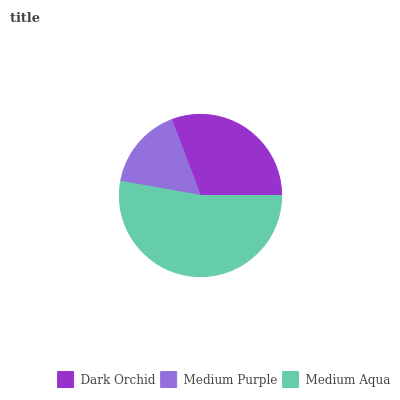Is Medium Purple the minimum?
Answer yes or no. Yes. Is Medium Aqua the maximum?
Answer yes or no. Yes. Is Medium Aqua the minimum?
Answer yes or no. No. Is Medium Purple the maximum?
Answer yes or no. No. Is Medium Aqua greater than Medium Purple?
Answer yes or no. Yes. Is Medium Purple less than Medium Aqua?
Answer yes or no. Yes. Is Medium Purple greater than Medium Aqua?
Answer yes or no. No. Is Medium Aqua less than Medium Purple?
Answer yes or no. No. Is Dark Orchid the high median?
Answer yes or no. Yes. Is Dark Orchid the low median?
Answer yes or no. Yes. Is Medium Aqua the high median?
Answer yes or no. No. Is Medium Purple the low median?
Answer yes or no. No. 